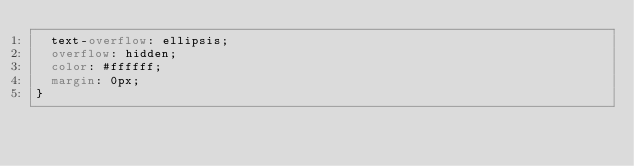<code> <loc_0><loc_0><loc_500><loc_500><_CSS_>  text-overflow: ellipsis;
  overflow: hidden;
  color: #ffffff;
  margin: 0px;
}
</code> 